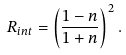<formula> <loc_0><loc_0><loc_500><loc_500>R _ { i n t } = \left ( \frac { 1 - n } { 1 + n } \right ) ^ { 2 } .</formula> 